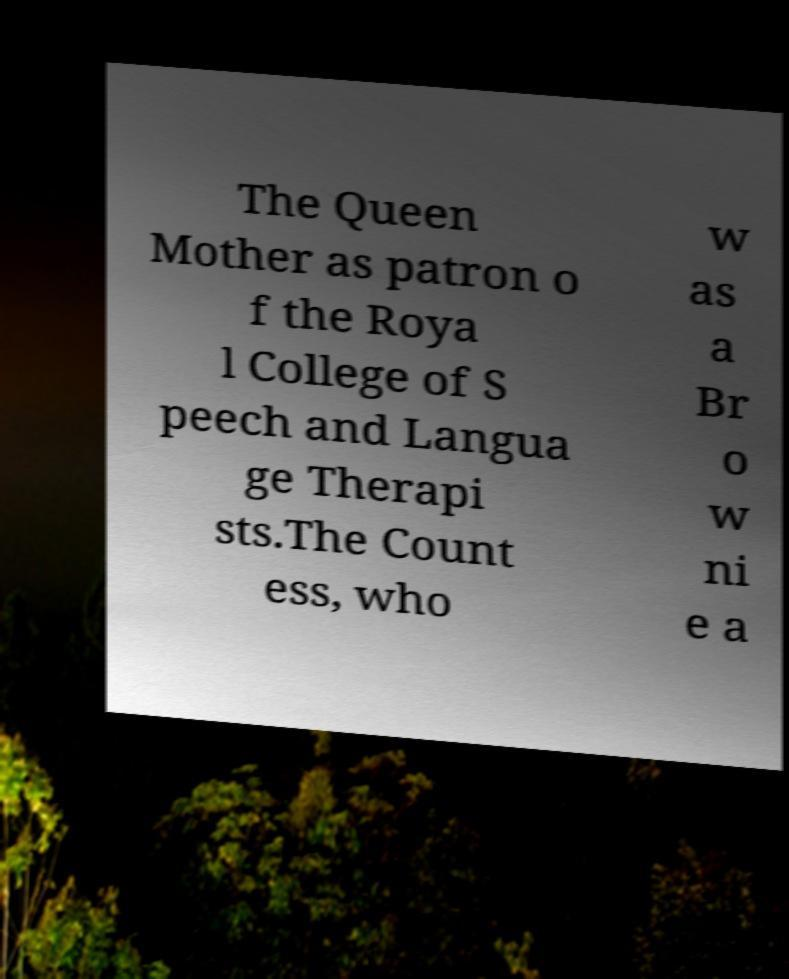For documentation purposes, I need the text within this image transcribed. Could you provide that? The Queen Mother as patron o f the Roya l College of S peech and Langua ge Therapi sts.The Count ess, who w as a Br o w ni e a 